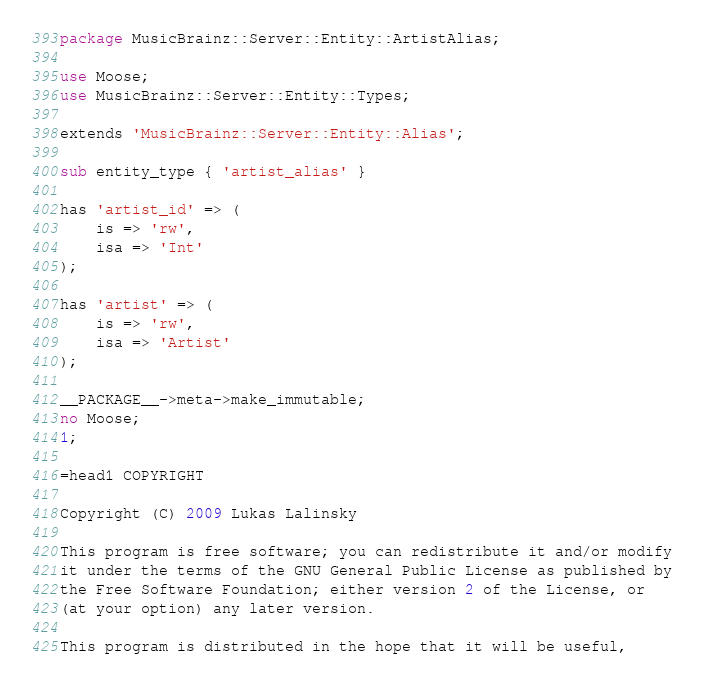Convert code to text. <code><loc_0><loc_0><loc_500><loc_500><_Perl_>package MusicBrainz::Server::Entity::ArtistAlias;

use Moose;
use MusicBrainz::Server::Entity::Types;

extends 'MusicBrainz::Server::Entity::Alias';

sub entity_type { 'artist_alias' }

has 'artist_id' => (
    is => 'rw',
    isa => 'Int'
);

has 'artist' => (
    is => 'rw',
    isa => 'Artist'
);

__PACKAGE__->meta->make_immutable;
no Moose;
1;

=head1 COPYRIGHT

Copyright (C) 2009 Lukas Lalinsky

This program is free software; you can redistribute it and/or modify
it under the terms of the GNU General Public License as published by
the Free Software Foundation; either version 2 of the License, or
(at your option) any later version.

This program is distributed in the hope that it will be useful,</code> 